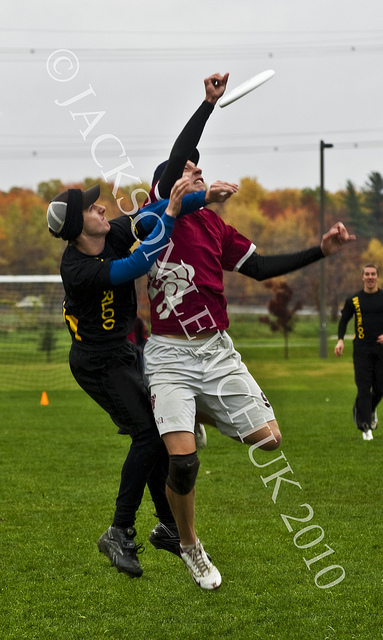<image>What number is on the black shirt? I don't know what number is on the black shirt. The responses vary from '0','1','2','5','8' and '30'. What number is on the black shirt? I am not sure what number is on the black shirt. It can be seen '30', '5', '8', '2', '1', or '0'. 